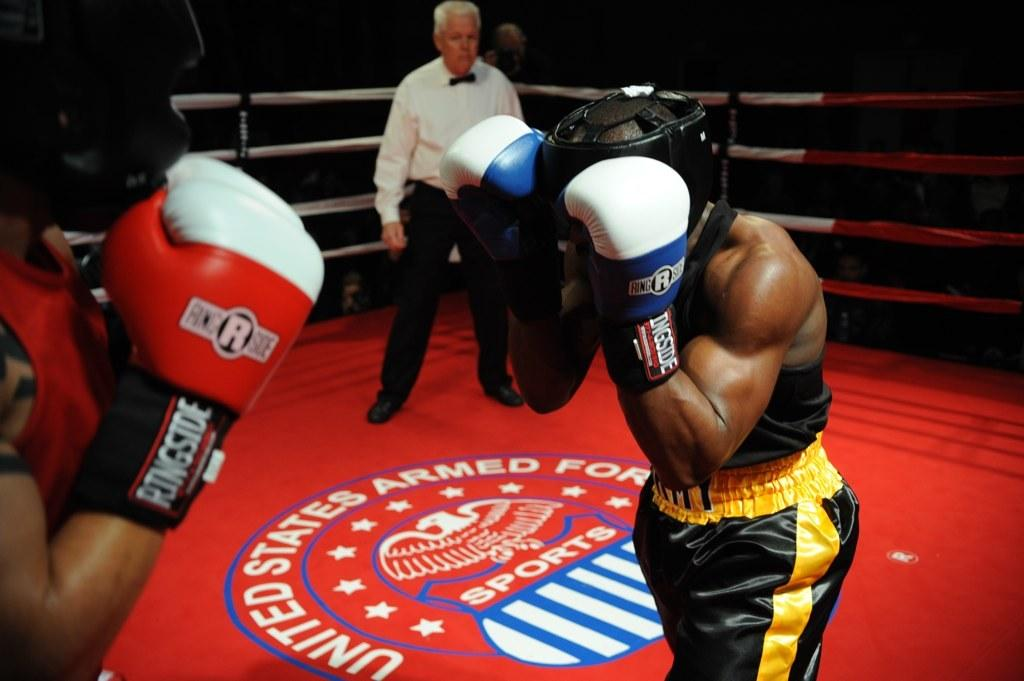What activity are the two people in the image engaged in? The two people in the image are boxing. Where is the boxing taking place? The boxing is taking place in a field. Can you describe the person standing behind the boxers? There is a man standing behind the boxers, and he is watching the boxing play. What type of flesh can be seen floating in the water near the boxers? There is no water or flesh present in the image; it features two people boxing in a field. 